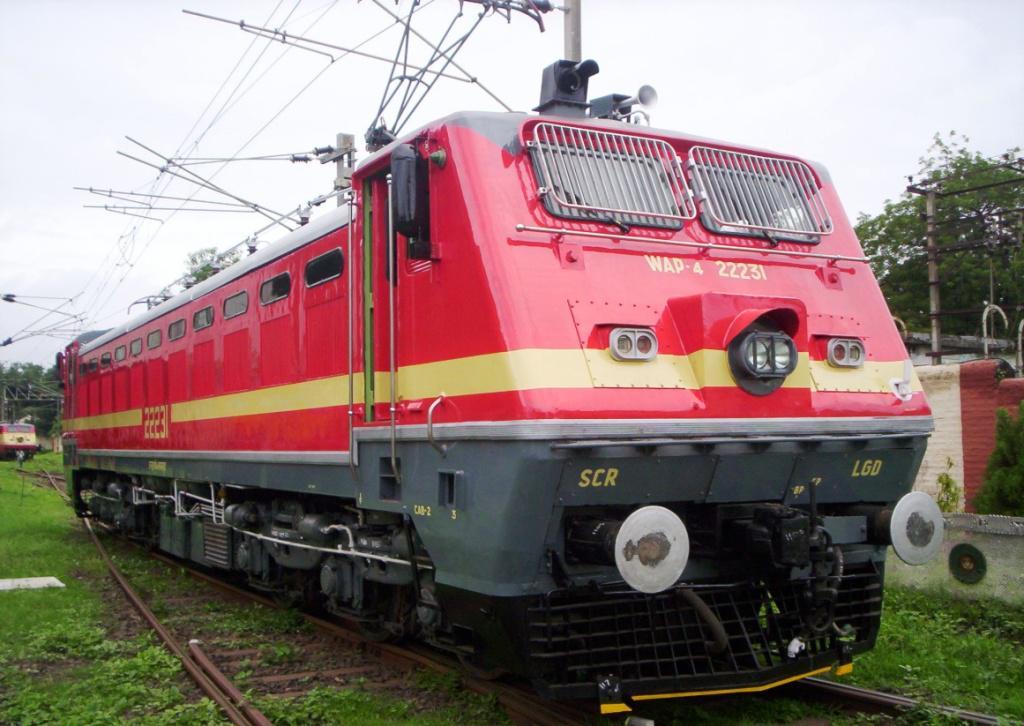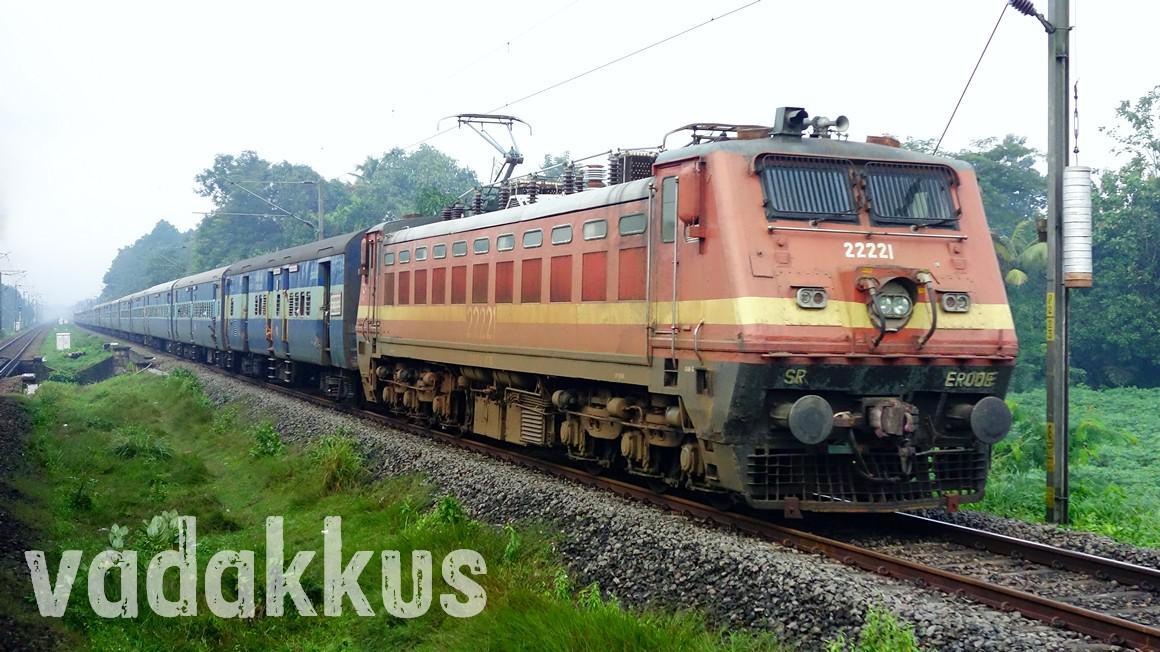The first image is the image on the left, the second image is the image on the right. Assess this claim about the two images: "The image on the right contains a green and yellow train.". Correct or not? Answer yes or no. No. 